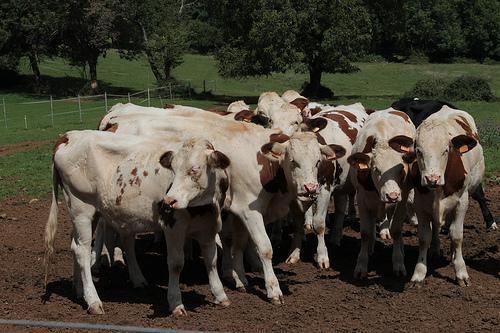How many faces are shown?
Give a very brief answer. 4. How many cows are not facing the camera?
Give a very brief answer. 1. 